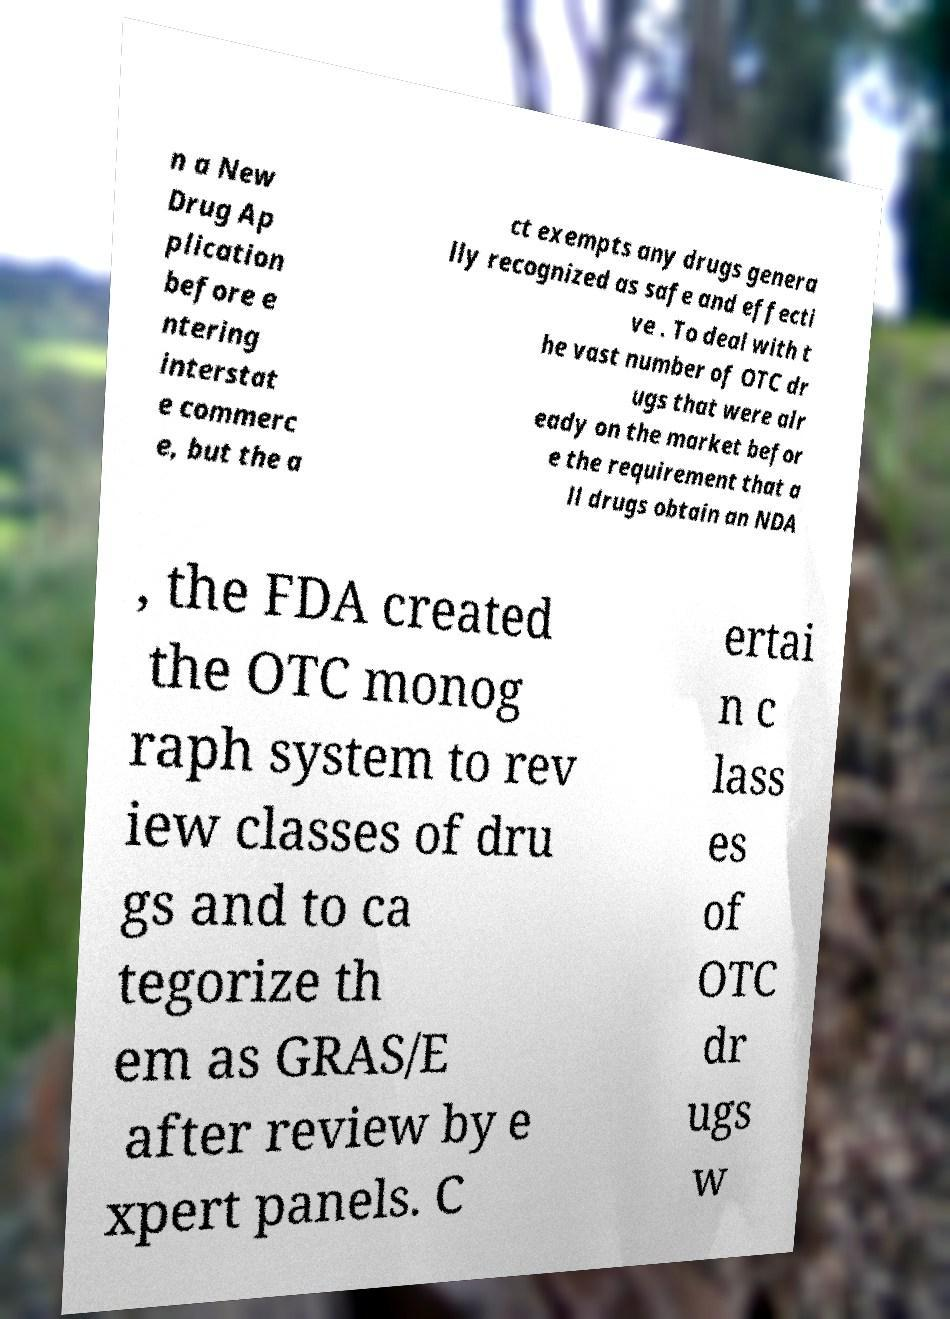I need the written content from this picture converted into text. Can you do that? n a New Drug Ap plication before e ntering interstat e commerc e, but the a ct exempts any drugs genera lly recognized as safe and effecti ve . To deal with t he vast number of OTC dr ugs that were alr eady on the market befor e the requirement that a ll drugs obtain an NDA , the FDA created the OTC monog raph system to rev iew classes of dru gs and to ca tegorize th em as GRAS/E after review by e xpert panels. C ertai n c lass es of OTC dr ugs w 